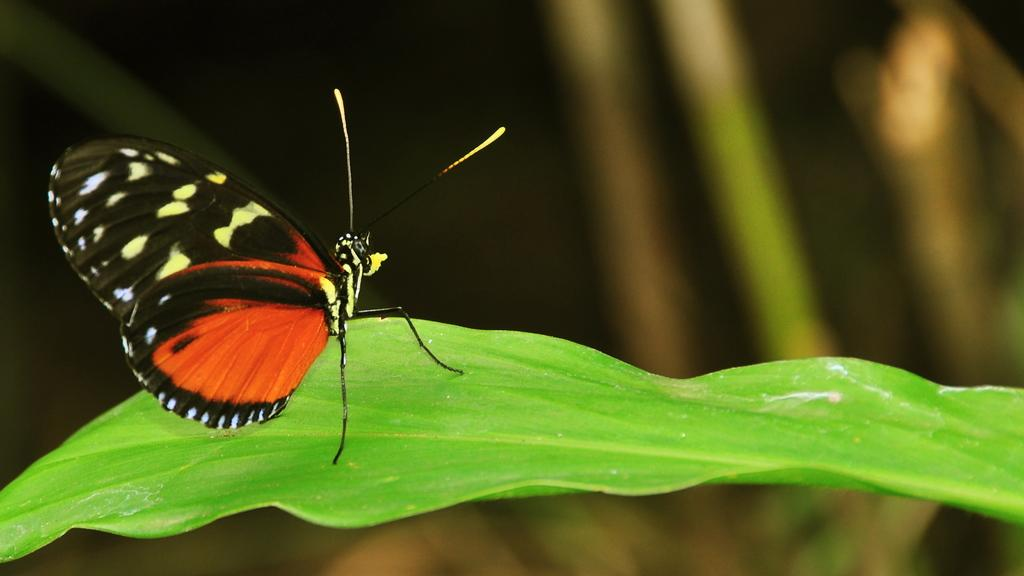What is the main subject of the image? There is a butterfly in the image. Where is the butterfly located in the image? The butterfly is sitting on a leaf. What can be observed about the butterfly's appearance? The butterfly has colorful wings. Can you describe the background of the image? The backdrop of the image is blurred. How many people are in the crowd behind the butterfly in the image? There is no crowd present in the image; it features a butterfly sitting on a leaf. What type of card is visible in the image? There is no card present in the image; it features a butterfly sitting on a leaf. 